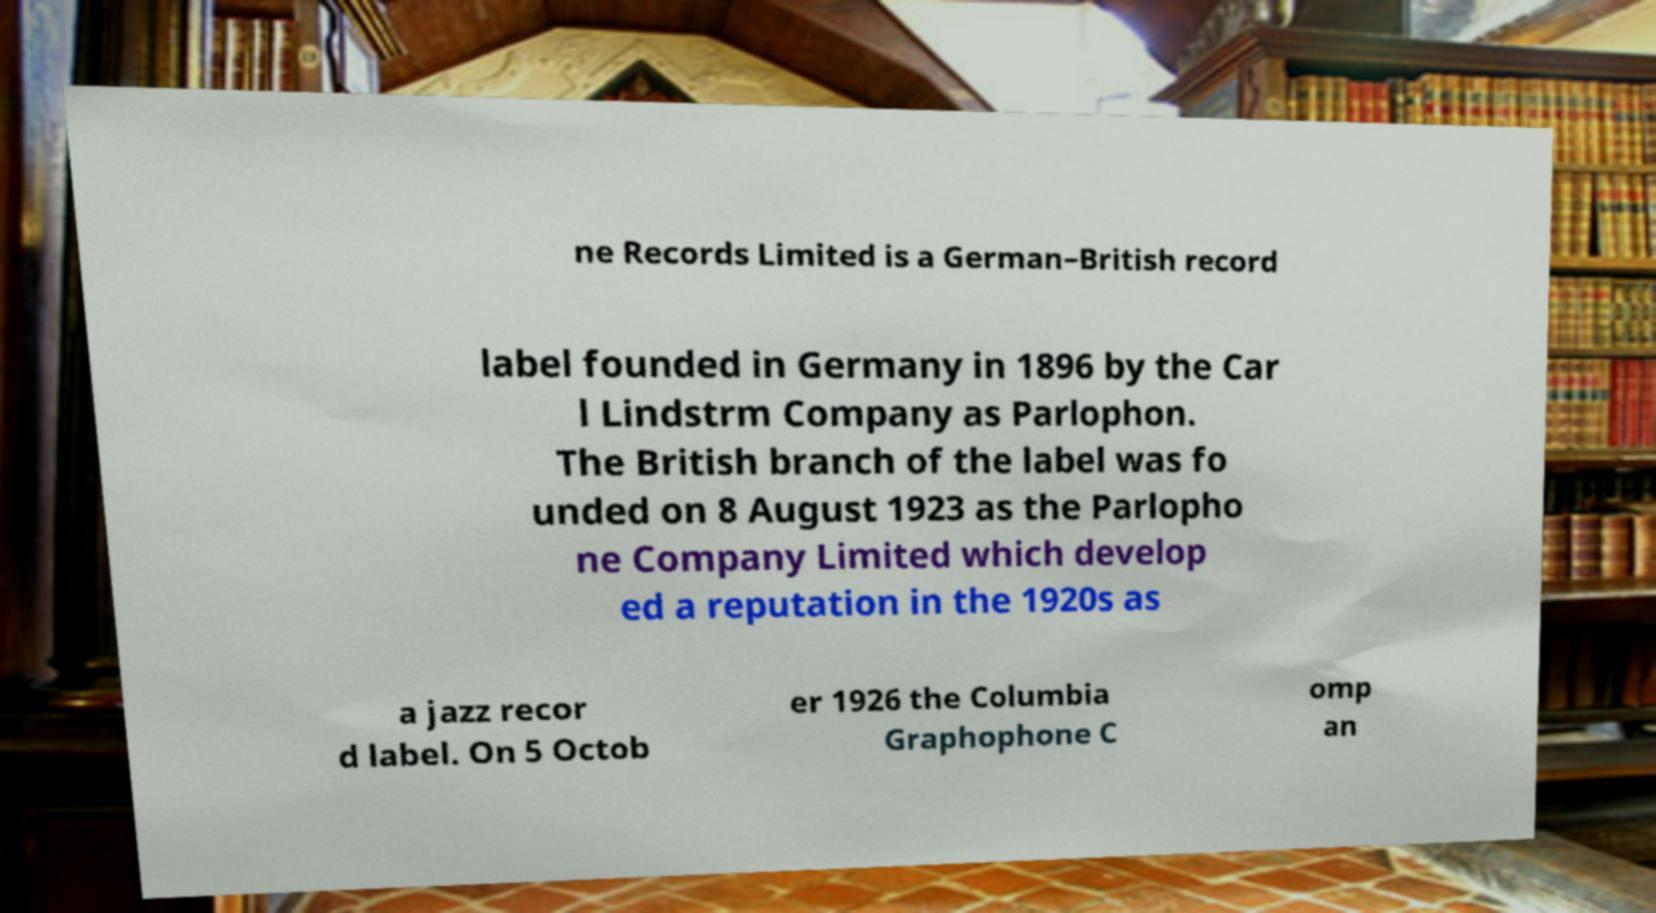I need the written content from this picture converted into text. Can you do that? ne Records Limited is a German–British record label founded in Germany in 1896 by the Car l Lindstrm Company as Parlophon. The British branch of the label was fo unded on 8 August 1923 as the Parlopho ne Company Limited which develop ed a reputation in the 1920s as a jazz recor d label. On 5 Octob er 1926 the Columbia Graphophone C omp an 